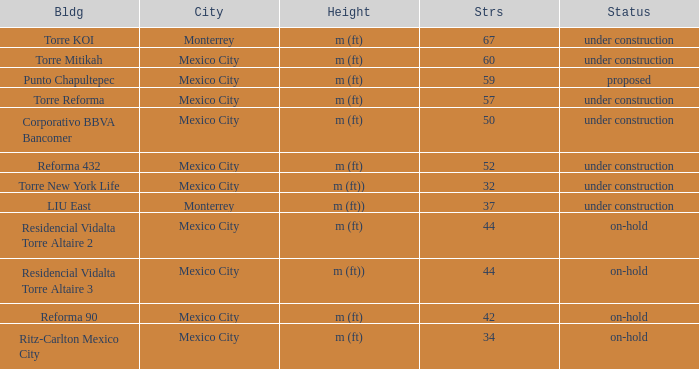What is the status of the torre reforma building that is over 44 stories in mexico city? Under construction. 